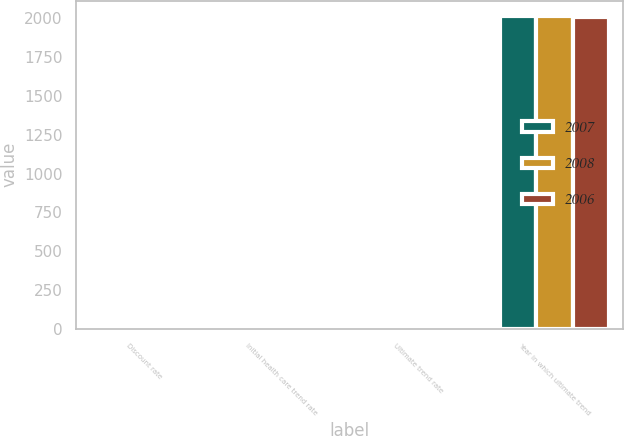<chart> <loc_0><loc_0><loc_500><loc_500><stacked_bar_chart><ecel><fcel>Discount rate<fcel>Initial health care trend rate<fcel>Ultimate trend rate<fcel>Year in which ultimate trend<nl><fcel>2007<fcel>6.3<fcel>9<fcel>4.5<fcel>2013<nl><fcel>2008<fcel>6.3<fcel>9<fcel>4.5<fcel>2013<nl><fcel>2006<fcel>5.8<fcel>8<fcel>4.5<fcel>2011<nl></chart> 